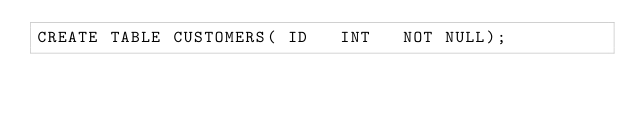Convert code to text. <code><loc_0><loc_0><loc_500><loc_500><_SQL_>CREATE TABLE CUSTOMERS( ID   INT   NOT NULL);
</code> 